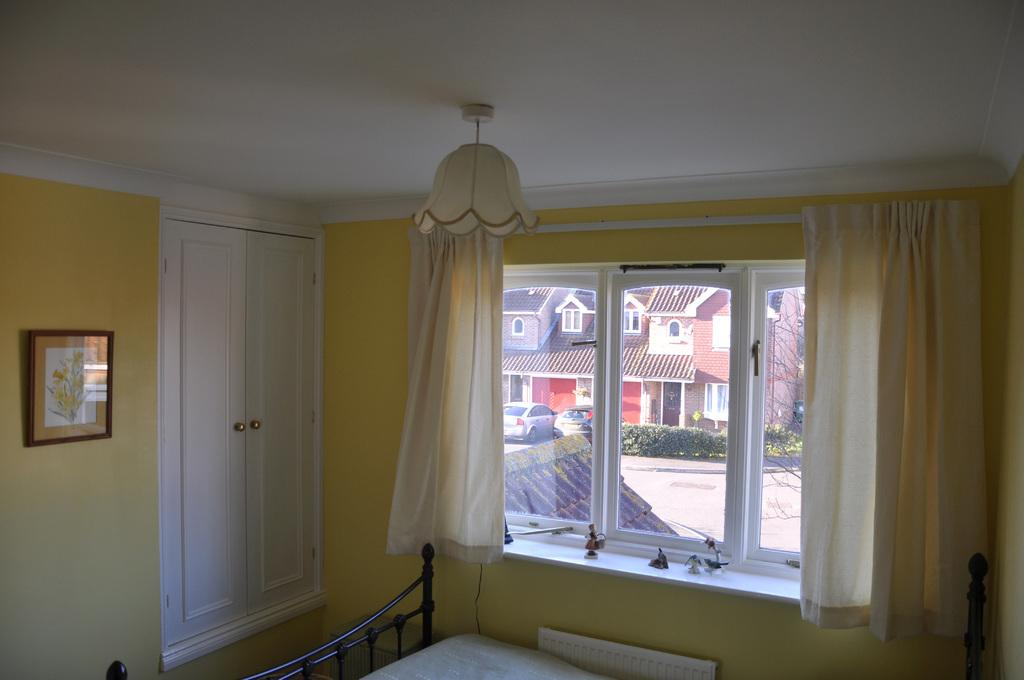What type of window treatment is visible in the image? There are curtains in the image. What can be seen through the windows in the image? There are houses, cars, plants, and a tree visible through the windows in the image. What type of decorative items are present in the image? There are photo frames in the image. What type of lighting is present in the image? There is a light in the image. What type of furniture is present in the image? There is a bed in the image. How many bikes are parked in front of the house in the image? There are no bikes present in the image. What type of books are visible on the bed in the image? There are no books visible on the bed in the image. 